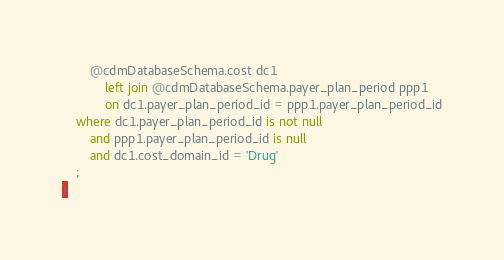<code> <loc_0><loc_0><loc_500><loc_500><_SQL_>		@cdmDatabaseSchema.cost dc1
			left join @cdmDatabaseSchema.payer_plan_period ppp1
			on dc1.payer_plan_period_id = ppp1.payer_plan_period_id
	where dc1.payer_plan_period_id is not null
		and ppp1.payer_plan_period_id is null
		and dc1.cost_domain_id = 'Drug'
	;
}
</code> 